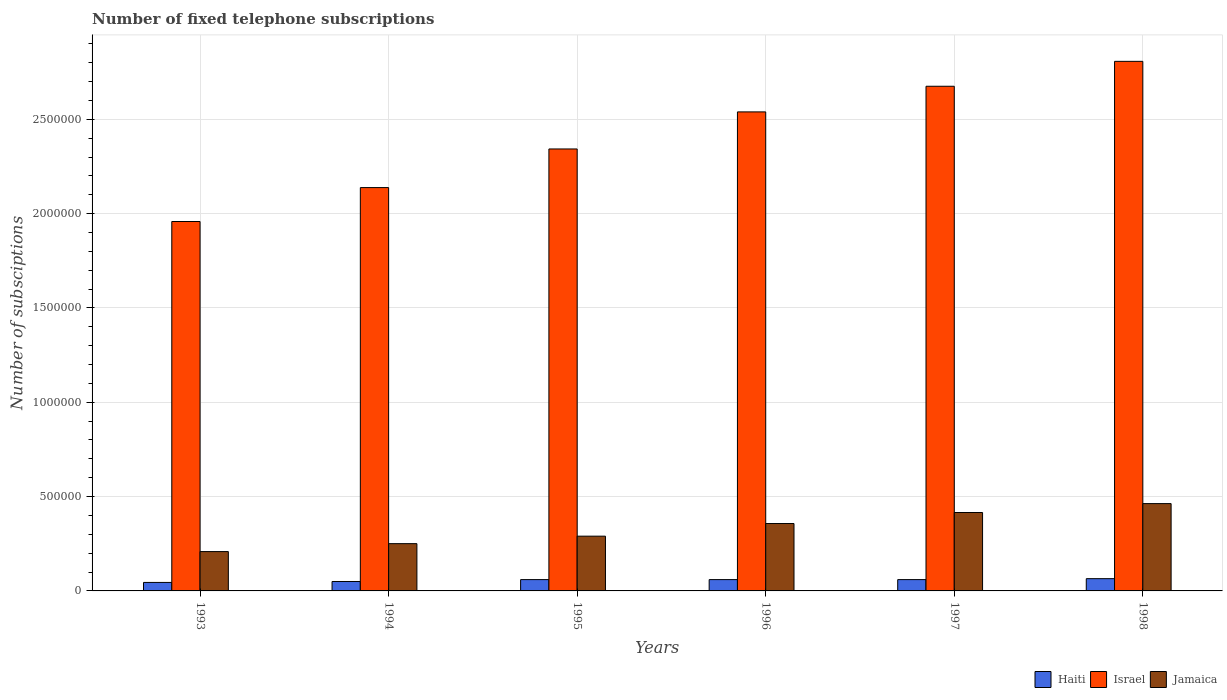Are the number of bars per tick equal to the number of legend labels?
Provide a succinct answer. Yes. What is the label of the 2nd group of bars from the left?
Make the answer very short. 1994. In how many cases, is the number of bars for a given year not equal to the number of legend labels?
Offer a terse response. 0. What is the number of fixed telephone subscriptions in Haiti in 1996?
Give a very brief answer. 6.00e+04. Across all years, what is the maximum number of fixed telephone subscriptions in Jamaica?
Give a very brief answer. 4.63e+05. Across all years, what is the minimum number of fixed telephone subscriptions in Israel?
Ensure brevity in your answer.  1.96e+06. What is the total number of fixed telephone subscriptions in Israel in the graph?
Give a very brief answer. 1.45e+07. What is the difference between the number of fixed telephone subscriptions in Jamaica in 1995 and that in 1996?
Offer a very short reply. -6.70e+04. What is the difference between the number of fixed telephone subscriptions in Jamaica in 1997 and the number of fixed telephone subscriptions in Haiti in 1995?
Ensure brevity in your answer.  3.56e+05. What is the average number of fixed telephone subscriptions in Haiti per year?
Keep it short and to the point. 5.67e+04. In the year 1994, what is the difference between the number of fixed telephone subscriptions in Israel and number of fixed telephone subscriptions in Jamaica?
Ensure brevity in your answer.  1.89e+06. In how many years, is the number of fixed telephone subscriptions in Israel greater than 2800000?
Offer a terse response. 1. What is the ratio of the number of fixed telephone subscriptions in Israel in 1994 to that in 1996?
Your answer should be compact. 0.84. Is the number of fixed telephone subscriptions in Israel in 1994 less than that in 1997?
Provide a short and direct response. Yes. Is the difference between the number of fixed telephone subscriptions in Israel in 1996 and 1998 greater than the difference between the number of fixed telephone subscriptions in Jamaica in 1996 and 1998?
Your answer should be very brief. No. What is the difference between the highest and the second highest number of fixed telephone subscriptions in Israel?
Your response must be concise. 1.32e+05. What is the difference between the highest and the lowest number of fixed telephone subscriptions in Jamaica?
Provide a short and direct response. 2.54e+05. In how many years, is the number of fixed telephone subscriptions in Jamaica greater than the average number of fixed telephone subscriptions in Jamaica taken over all years?
Your answer should be compact. 3. Is the sum of the number of fixed telephone subscriptions in Jamaica in 1993 and 1998 greater than the maximum number of fixed telephone subscriptions in Israel across all years?
Ensure brevity in your answer.  No. What does the 1st bar from the left in 1993 represents?
Provide a succinct answer. Haiti. What does the 3rd bar from the right in 1998 represents?
Make the answer very short. Haiti. Is it the case that in every year, the sum of the number of fixed telephone subscriptions in Jamaica and number of fixed telephone subscriptions in Israel is greater than the number of fixed telephone subscriptions in Haiti?
Keep it short and to the point. Yes. How many bars are there?
Your answer should be very brief. 18. Are all the bars in the graph horizontal?
Offer a terse response. No. How many years are there in the graph?
Keep it short and to the point. 6. Are the values on the major ticks of Y-axis written in scientific E-notation?
Your answer should be very brief. No. Does the graph contain any zero values?
Give a very brief answer. No. Does the graph contain grids?
Your answer should be very brief. Yes. Where does the legend appear in the graph?
Provide a short and direct response. Bottom right. How many legend labels are there?
Provide a succinct answer. 3. What is the title of the graph?
Your answer should be very brief. Number of fixed telephone subscriptions. Does "Armenia" appear as one of the legend labels in the graph?
Offer a very short reply. No. What is the label or title of the Y-axis?
Provide a succinct answer. Number of subsciptions. What is the Number of subsciptions of Haiti in 1993?
Offer a very short reply. 4.50e+04. What is the Number of subsciptions of Israel in 1993?
Ensure brevity in your answer.  1.96e+06. What is the Number of subsciptions of Jamaica in 1993?
Make the answer very short. 2.08e+05. What is the Number of subsciptions in Haiti in 1994?
Make the answer very short. 5.00e+04. What is the Number of subsciptions in Israel in 1994?
Provide a short and direct response. 2.14e+06. What is the Number of subsciptions of Jamaica in 1994?
Offer a terse response. 2.51e+05. What is the Number of subsciptions in Haiti in 1995?
Offer a very short reply. 6.00e+04. What is the Number of subsciptions of Israel in 1995?
Offer a terse response. 2.34e+06. What is the Number of subsciptions of Jamaica in 1995?
Ensure brevity in your answer.  2.90e+05. What is the Number of subsciptions in Haiti in 1996?
Keep it short and to the point. 6.00e+04. What is the Number of subsciptions in Israel in 1996?
Provide a succinct answer. 2.54e+06. What is the Number of subsciptions in Jamaica in 1996?
Offer a terse response. 3.57e+05. What is the Number of subsciptions in Israel in 1997?
Provide a succinct answer. 2.68e+06. What is the Number of subsciptions in Jamaica in 1997?
Ensure brevity in your answer.  4.16e+05. What is the Number of subsciptions of Haiti in 1998?
Give a very brief answer. 6.50e+04. What is the Number of subsciptions of Israel in 1998?
Your answer should be compact. 2.81e+06. What is the Number of subsciptions of Jamaica in 1998?
Offer a very short reply. 4.63e+05. Across all years, what is the maximum Number of subsciptions of Haiti?
Provide a short and direct response. 6.50e+04. Across all years, what is the maximum Number of subsciptions in Israel?
Provide a succinct answer. 2.81e+06. Across all years, what is the maximum Number of subsciptions in Jamaica?
Offer a very short reply. 4.63e+05. Across all years, what is the minimum Number of subsciptions in Haiti?
Your answer should be compact. 4.50e+04. Across all years, what is the minimum Number of subsciptions in Israel?
Ensure brevity in your answer.  1.96e+06. Across all years, what is the minimum Number of subsciptions of Jamaica?
Your response must be concise. 2.08e+05. What is the total Number of subsciptions of Haiti in the graph?
Provide a succinct answer. 3.40e+05. What is the total Number of subsciptions of Israel in the graph?
Keep it short and to the point. 1.45e+07. What is the total Number of subsciptions in Jamaica in the graph?
Provide a short and direct response. 1.98e+06. What is the difference between the Number of subsciptions in Haiti in 1993 and that in 1994?
Make the answer very short. -4990. What is the difference between the Number of subsciptions in Israel in 1993 and that in 1994?
Offer a very short reply. -1.80e+05. What is the difference between the Number of subsciptions in Jamaica in 1993 and that in 1994?
Offer a very short reply. -4.21e+04. What is the difference between the Number of subsciptions in Haiti in 1993 and that in 1995?
Offer a terse response. -1.50e+04. What is the difference between the Number of subsciptions of Israel in 1993 and that in 1995?
Give a very brief answer. -3.85e+05. What is the difference between the Number of subsciptions in Jamaica in 1993 and that in 1995?
Your answer should be very brief. -8.18e+04. What is the difference between the Number of subsciptions in Haiti in 1993 and that in 1996?
Provide a succinct answer. -1.50e+04. What is the difference between the Number of subsciptions of Israel in 1993 and that in 1996?
Your answer should be very brief. -5.81e+05. What is the difference between the Number of subsciptions of Jamaica in 1993 and that in 1996?
Provide a short and direct response. -1.49e+05. What is the difference between the Number of subsciptions of Haiti in 1993 and that in 1997?
Offer a terse response. -1.50e+04. What is the difference between the Number of subsciptions of Israel in 1993 and that in 1997?
Give a very brief answer. -7.17e+05. What is the difference between the Number of subsciptions of Jamaica in 1993 and that in 1997?
Make the answer very short. -2.07e+05. What is the difference between the Number of subsciptions in Haiti in 1993 and that in 1998?
Make the answer very short. -2.00e+04. What is the difference between the Number of subsciptions in Israel in 1993 and that in 1998?
Your answer should be compact. -8.49e+05. What is the difference between the Number of subsciptions of Jamaica in 1993 and that in 1998?
Provide a succinct answer. -2.54e+05. What is the difference between the Number of subsciptions of Israel in 1994 and that in 1995?
Your response must be concise. -2.05e+05. What is the difference between the Number of subsciptions of Jamaica in 1994 and that in 1995?
Make the answer very short. -3.97e+04. What is the difference between the Number of subsciptions of Israel in 1994 and that in 1996?
Provide a succinct answer. -4.01e+05. What is the difference between the Number of subsciptions in Jamaica in 1994 and that in 1996?
Offer a very short reply. -1.07e+05. What is the difference between the Number of subsciptions of Israel in 1994 and that in 1997?
Your answer should be very brief. -5.37e+05. What is the difference between the Number of subsciptions in Jamaica in 1994 and that in 1997?
Offer a terse response. -1.65e+05. What is the difference between the Number of subsciptions in Haiti in 1994 and that in 1998?
Provide a succinct answer. -1.50e+04. What is the difference between the Number of subsciptions in Israel in 1994 and that in 1998?
Your answer should be very brief. -6.69e+05. What is the difference between the Number of subsciptions in Jamaica in 1994 and that in 1998?
Make the answer very short. -2.12e+05. What is the difference between the Number of subsciptions of Israel in 1995 and that in 1996?
Provide a succinct answer. -1.96e+05. What is the difference between the Number of subsciptions in Jamaica in 1995 and that in 1996?
Keep it short and to the point. -6.70e+04. What is the difference between the Number of subsciptions of Israel in 1995 and that in 1997?
Provide a succinct answer. -3.32e+05. What is the difference between the Number of subsciptions in Jamaica in 1995 and that in 1997?
Provide a short and direct response. -1.25e+05. What is the difference between the Number of subsciptions in Haiti in 1995 and that in 1998?
Give a very brief answer. -5000. What is the difference between the Number of subsciptions of Israel in 1995 and that in 1998?
Your response must be concise. -4.64e+05. What is the difference between the Number of subsciptions of Jamaica in 1995 and that in 1998?
Give a very brief answer. -1.73e+05. What is the difference between the Number of subsciptions of Haiti in 1996 and that in 1997?
Make the answer very short. 0. What is the difference between the Number of subsciptions in Israel in 1996 and that in 1997?
Your answer should be compact. -1.36e+05. What is the difference between the Number of subsciptions of Jamaica in 1996 and that in 1997?
Provide a succinct answer. -5.83e+04. What is the difference between the Number of subsciptions in Haiti in 1996 and that in 1998?
Offer a very short reply. -5000. What is the difference between the Number of subsciptions in Israel in 1996 and that in 1998?
Offer a very short reply. -2.68e+05. What is the difference between the Number of subsciptions of Jamaica in 1996 and that in 1998?
Provide a succinct answer. -1.06e+05. What is the difference between the Number of subsciptions in Haiti in 1997 and that in 1998?
Your answer should be very brief. -5000. What is the difference between the Number of subsciptions of Israel in 1997 and that in 1998?
Offer a terse response. -1.32e+05. What is the difference between the Number of subsciptions in Jamaica in 1997 and that in 1998?
Your answer should be very brief. -4.72e+04. What is the difference between the Number of subsciptions of Haiti in 1993 and the Number of subsciptions of Israel in 1994?
Give a very brief answer. -2.09e+06. What is the difference between the Number of subsciptions of Haiti in 1993 and the Number of subsciptions of Jamaica in 1994?
Offer a terse response. -2.06e+05. What is the difference between the Number of subsciptions in Israel in 1993 and the Number of subsciptions in Jamaica in 1994?
Offer a terse response. 1.71e+06. What is the difference between the Number of subsciptions in Haiti in 1993 and the Number of subsciptions in Israel in 1995?
Ensure brevity in your answer.  -2.30e+06. What is the difference between the Number of subsciptions of Haiti in 1993 and the Number of subsciptions of Jamaica in 1995?
Keep it short and to the point. -2.45e+05. What is the difference between the Number of subsciptions of Israel in 1993 and the Number of subsciptions of Jamaica in 1995?
Offer a very short reply. 1.67e+06. What is the difference between the Number of subsciptions in Haiti in 1993 and the Number of subsciptions in Israel in 1996?
Keep it short and to the point. -2.49e+06. What is the difference between the Number of subsciptions of Haiti in 1993 and the Number of subsciptions of Jamaica in 1996?
Keep it short and to the point. -3.12e+05. What is the difference between the Number of subsciptions in Israel in 1993 and the Number of subsciptions in Jamaica in 1996?
Offer a very short reply. 1.60e+06. What is the difference between the Number of subsciptions in Haiti in 1993 and the Number of subsciptions in Israel in 1997?
Provide a short and direct response. -2.63e+06. What is the difference between the Number of subsciptions in Haiti in 1993 and the Number of subsciptions in Jamaica in 1997?
Keep it short and to the point. -3.71e+05. What is the difference between the Number of subsciptions of Israel in 1993 and the Number of subsciptions of Jamaica in 1997?
Your response must be concise. 1.54e+06. What is the difference between the Number of subsciptions of Haiti in 1993 and the Number of subsciptions of Israel in 1998?
Ensure brevity in your answer.  -2.76e+06. What is the difference between the Number of subsciptions of Haiti in 1993 and the Number of subsciptions of Jamaica in 1998?
Offer a very short reply. -4.18e+05. What is the difference between the Number of subsciptions in Israel in 1993 and the Number of subsciptions in Jamaica in 1998?
Your response must be concise. 1.50e+06. What is the difference between the Number of subsciptions of Haiti in 1994 and the Number of subsciptions of Israel in 1995?
Offer a very short reply. -2.29e+06. What is the difference between the Number of subsciptions in Haiti in 1994 and the Number of subsciptions in Jamaica in 1995?
Your response must be concise. -2.40e+05. What is the difference between the Number of subsciptions of Israel in 1994 and the Number of subsciptions of Jamaica in 1995?
Your answer should be compact. 1.85e+06. What is the difference between the Number of subsciptions in Haiti in 1994 and the Number of subsciptions in Israel in 1996?
Your answer should be very brief. -2.49e+06. What is the difference between the Number of subsciptions of Haiti in 1994 and the Number of subsciptions of Jamaica in 1996?
Ensure brevity in your answer.  -3.07e+05. What is the difference between the Number of subsciptions of Israel in 1994 and the Number of subsciptions of Jamaica in 1996?
Make the answer very short. 1.78e+06. What is the difference between the Number of subsciptions in Haiti in 1994 and the Number of subsciptions in Israel in 1997?
Your answer should be compact. -2.62e+06. What is the difference between the Number of subsciptions of Haiti in 1994 and the Number of subsciptions of Jamaica in 1997?
Keep it short and to the point. -3.66e+05. What is the difference between the Number of subsciptions in Israel in 1994 and the Number of subsciptions in Jamaica in 1997?
Offer a terse response. 1.72e+06. What is the difference between the Number of subsciptions of Haiti in 1994 and the Number of subsciptions of Israel in 1998?
Your response must be concise. -2.76e+06. What is the difference between the Number of subsciptions of Haiti in 1994 and the Number of subsciptions of Jamaica in 1998?
Your answer should be very brief. -4.13e+05. What is the difference between the Number of subsciptions in Israel in 1994 and the Number of subsciptions in Jamaica in 1998?
Your answer should be very brief. 1.68e+06. What is the difference between the Number of subsciptions in Haiti in 1995 and the Number of subsciptions in Israel in 1996?
Give a very brief answer. -2.48e+06. What is the difference between the Number of subsciptions of Haiti in 1995 and the Number of subsciptions of Jamaica in 1996?
Ensure brevity in your answer.  -2.97e+05. What is the difference between the Number of subsciptions of Israel in 1995 and the Number of subsciptions of Jamaica in 1996?
Provide a succinct answer. 1.99e+06. What is the difference between the Number of subsciptions of Haiti in 1995 and the Number of subsciptions of Israel in 1997?
Keep it short and to the point. -2.62e+06. What is the difference between the Number of subsciptions in Haiti in 1995 and the Number of subsciptions in Jamaica in 1997?
Make the answer very short. -3.56e+05. What is the difference between the Number of subsciptions of Israel in 1995 and the Number of subsciptions of Jamaica in 1997?
Offer a terse response. 1.93e+06. What is the difference between the Number of subsciptions of Haiti in 1995 and the Number of subsciptions of Israel in 1998?
Your answer should be very brief. -2.75e+06. What is the difference between the Number of subsciptions in Haiti in 1995 and the Number of subsciptions in Jamaica in 1998?
Your response must be concise. -4.03e+05. What is the difference between the Number of subsciptions in Israel in 1995 and the Number of subsciptions in Jamaica in 1998?
Offer a terse response. 1.88e+06. What is the difference between the Number of subsciptions of Haiti in 1996 and the Number of subsciptions of Israel in 1997?
Ensure brevity in your answer.  -2.62e+06. What is the difference between the Number of subsciptions of Haiti in 1996 and the Number of subsciptions of Jamaica in 1997?
Provide a short and direct response. -3.56e+05. What is the difference between the Number of subsciptions of Israel in 1996 and the Number of subsciptions of Jamaica in 1997?
Your answer should be very brief. 2.12e+06. What is the difference between the Number of subsciptions of Haiti in 1996 and the Number of subsciptions of Israel in 1998?
Keep it short and to the point. -2.75e+06. What is the difference between the Number of subsciptions of Haiti in 1996 and the Number of subsciptions of Jamaica in 1998?
Ensure brevity in your answer.  -4.03e+05. What is the difference between the Number of subsciptions of Israel in 1996 and the Number of subsciptions of Jamaica in 1998?
Make the answer very short. 2.08e+06. What is the difference between the Number of subsciptions in Haiti in 1997 and the Number of subsciptions in Israel in 1998?
Your answer should be compact. -2.75e+06. What is the difference between the Number of subsciptions in Haiti in 1997 and the Number of subsciptions in Jamaica in 1998?
Your answer should be compact. -4.03e+05. What is the difference between the Number of subsciptions of Israel in 1997 and the Number of subsciptions of Jamaica in 1998?
Offer a terse response. 2.21e+06. What is the average Number of subsciptions of Haiti per year?
Provide a short and direct response. 5.67e+04. What is the average Number of subsciptions in Israel per year?
Your answer should be compact. 2.41e+06. What is the average Number of subsciptions in Jamaica per year?
Provide a short and direct response. 3.31e+05. In the year 1993, what is the difference between the Number of subsciptions of Haiti and Number of subsciptions of Israel?
Your answer should be very brief. -1.91e+06. In the year 1993, what is the difference between the Number of subsciptions of Haiti and Number of subsciptions of Jamaica?
Your response must be concise. -1.63e+05. In the year 1993, what is the difference between the Number of subsciptions in Israel and Number of subsciptions in Jamaica?
Your response must be concise. 1.75e+06. In the year 1994, what is the difference between the Number of subsciptions of Haiti and Number of subsciptions of Israel?
Your response must be concise. -2.09e+06. In the year 1994, what is the difference between the Number of subsciptions of Haiti and Number of subsciptions of Jamaica?
Your response must be concise. -2.01e+05. In the year 1994, what is the difference between the Number of subsciptions in Israel and Number of subsciptions in Jamaica?
Keep it short and to the point. 1.89e+06. In the year 1995, what is the difference between the Number of subsciptions in Haiti and Number of subsciptions in Israel?
Keep it short and to the point. -2.28e+06. In the year 1995, what is the difference between the Number of subsciptions in Haiti and Number of subsciptions in Jamaica?
Your answer should be compact. -2.30e+05. In the year 1995, what is the difference between the Number of subsciptions in Israel and Number of subsciptions in Jamaica?
Ensure brevity in your answer.  2.05e+06. In the year 1996, what is the difference between the Number of subsciptions in Haiti and Number of subsciptions in Israel?
Offer a terse response. -2.48e+06. In the year 1996, what is the difference between the Number of subsciptions of Haiti and Number of subsciptions of Jamaica?
Your answer should be compact. -2.97e+05. In the year 1996, what is the difference between the Number of subsciptions of Israel and Number of subsciptions of Jamaica?
Offer a terse response. 2.18e+06. In the year 1997, what is the difference between the Number of subsciptions in Haiti and Number of subsciptions in Israel?
Your answer should be compact. -2.62e+06. In the year 1997, what is the difference between the Number of subsciptions in Haiti and Number of subsciptions in Jamaica?
Provide a succinct answer. -3.56e+05. In the year 1997, what is the difference between the Number of subsciptions in Israel and Number of subsciptions in Jamaica?
Your answer should be very brief. 2.26e+06. In the year 1998, what is the difference between the Number of subsciptions in Haiti and Number of subsciptions in Israel?
Make the answer very short. -2.74e+06. In the year 1998, what is the difference between the Number of subsciptions in Haiti and Number of subsciptions in Jamaica?
Offer a terse response. -3.98e+05. In the year 1998, what is the difference between the Number of subsciptions in Israel and Number of subsciptions in Jamaica?
Offer a terse response. 2.34e+06. What is the ratio of the Number of subsciptions in Haiti in 1993 to that in 1994?
Ensure brevity in your answer.  0.9. What is the ratio of the Number of subsciptions of Israel in 1993 to that in 1994?
Your answer should be very brief. 0.92. What is the ratio of the Number of subsciptions in Jamaica in 1993 to that in 1994?
Ensure brevity in your answer.  0.83. What is the ratio of the Number of subsciptions in Haiti in 1993 to that in 1995?
Your answer should be very brief. 0.75. What is the ratio of the Number of subsciptions of Israel in 1993 to that in 1995?
Ensure brevity in your answer.  0.84. What is the ratio of the Number of subsciptions in Jamaica in 1993 to that in 1995?
Offer a terse response. 0.72. What is the ratio of the Number of subsciptions of Haiti in 1993 to that in 1996?
Provide a succinct answer. 0.75. What is the ratio of the Number of subsciptions in Israel in 1993 to that in 1996?
Provide a succinct answer. 0.77. What is the ratio of the Number of subsciptions of Jamaica in 1993 to that in 1996?
Your response must be concise. 0.58. What is the ratio of the Number of subsciptions in Haiti in 1993 to that in 1997?
Offer a very short reply. 0.75. What is the ratio of the Number of subsciptions of Israel in 1993 to that in 1997?
Your answer should be very brief. 0.73. What is the ratio of the Number of subsciptions of Jamaica in 1993 to that in 1997?
Keep it short and to the point. 0.5. What is the ratio of the Number of subsciptions in Haiti in 1993 to that in 1998?
Your answer should be very brief. 0.69. What is the ratio of the Number of subsciptions of Israel in 1993 to that in 1998?
Your response must be concise. 0.7. What is the ratio of the Number of subsciptions of Jamaica in 1993 to that in 1998?
Offer a terse response. 0.45. What is the ratio of the Number of subsciptions of Israel in 1994 to that in 1995?
Give a very brief answer. 0.91. What is the ratio of the Number of subsciptions in Jamaica in 1994 to that in 1995?
Your response must be concise. 0.86. What is the ratio of the Number of subsciptions of Israel in 1994 to that in 1996?
Ensure brevity in your answer.  0.84. What is the ratio of the Number of subsciptions in Jamaica in 1994 to that in 1996?
Provide a succinct answer. 0.7. What is the ratio of the Number of subsciptions of Haiti in 1994 to that in 1997?
Ensure brevity in your answer.  0.83. What is the ratio of the Number of subsciptions of Israel in 1994 to that in 1997?
Offer a terse response. 0.8. What is the ratio of the Number of subsciptions of Jamaica in 1994 to that in 1997?
Make the answer very short. 0.6. What is the ratio of the Number of subsciptions in Haiti in 1994 to that in 1998?
Offer a terse response. 0.77. What is the ratio of the Number of subsciptions of Israel in 1994 to that in 1998?
Offer a terse response. 0.76. What is the ratio of the Number of subsciptions in Jamaica in 1994 to that in 1998?
Your answer should be compact. 0.54. What is the ratio of the Number of subsciptions of Haiti in 1995 to that in 1996?
Offer a terse response. 1. What is the ratio of the Number of subsciptions of Israel in 1995 to that in 1996?
Your answer should be very brief. 0.92. What is the ratio of the Number of subsciptions of Jamaica in 1995 to that in 1996?
Offer a very short reply. 0.81. What is the ratio of the Number of subsciptions in Israel in 1995 to that in 1997?
Keep it short and to the point. 0.88. What is the ratio of the Number of subsciptions in Jamaica in 1995 to that in 1997?
Offer a terse response. 0.7. What is the ratio of the Number of subsciptions in Israel in 1995 to that in 1998?
Provide a short and direct response. 0.83. What is the ratio of the Number of subsciptions in Jamaica in 1995 to that in 1998?
Offer a terse response. 0.63. What is the ratio of the Number of subsciptions in Haiti in 1996 to that in 1997?
Make the answer very short. 1. What is the ratio of the Number of subsciptions in Israel in 1996 to that in 1997?
Provide a succinct answer. 0.95. What is the ratio of the Number of subsciptions of Jamaica in 1996 to that in 1997?
Give a very brief answer. 0.86. What is the ratio of the Number of subsciptions in Israel in 1996 to that in 1998?
Your answer should be very brief. 0.9. What is the ratio of the Number of subsciptions in Jamaica in 1996 to that in 1998?
Your answer should be compact. 0.77. What is the ratio of the Number of subsciptions in Haiti in 1997 to that in 1998?
Provide a short and direct response. 0.92. What is the ratio of the Number of subsciptions of Israel in 1997 to that in 1998?
Your answer should be compact. 0.95. What is the ratio of the Number of subsciptions in Jamaica in 1997 to that in 1998?
Keep it short and to the point. 0.9. What is the difference between the highest and the second highest Number of subsciptions of Israel?
Offer a very short reply. 1.32e+05. What is the difference between the highest and the second highest Number of subsciptions of Jamaica?
Give a very brief answer. 4.72e+04. What is the difference between the highest and the lowest Number of subsciptions in Haiti?
Provide a short and direct response. 2.00e+04. What is the difference between the highest and the lowest Number of subsciptions of Israel?
Provide a succinct answer. 8.49e+05. What is the difference between the highest and the lowest Number of subsciptions of Jamaica?
Offer a very short reply. 2.54e+05. 